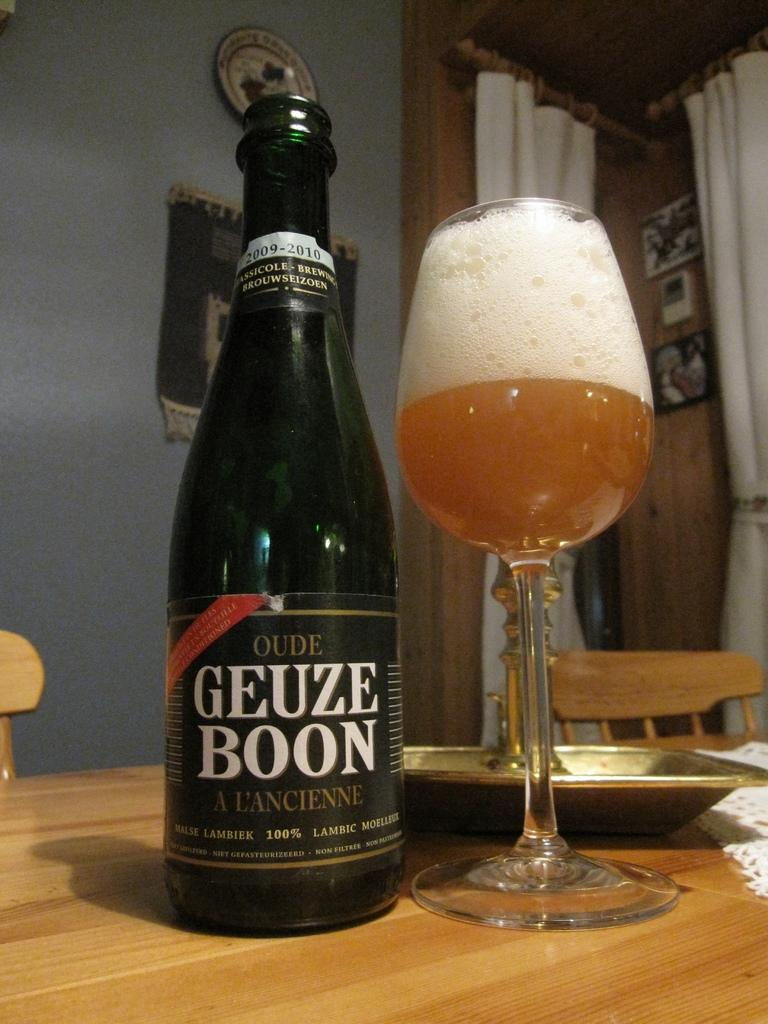Provide a one-sentence caption for the provided image. A bottle of Oude Geuze Boon is sitting next to a full glass on a table. 